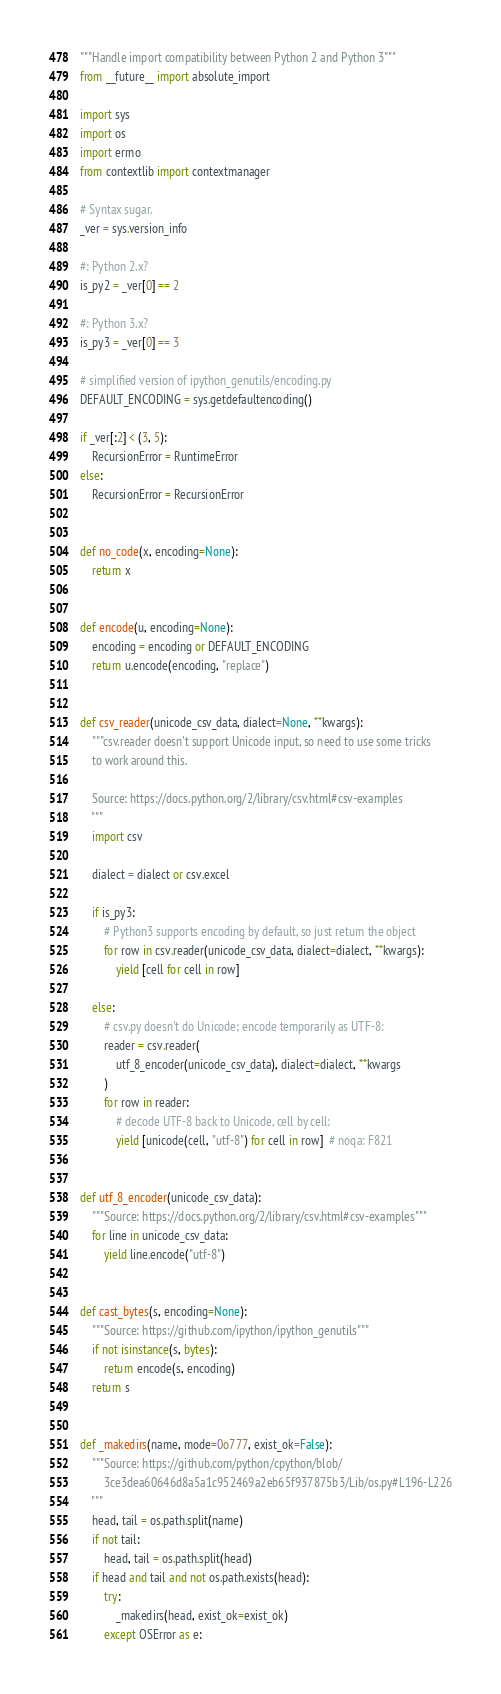<code> <loc_0><loc_0><loc_500><loc_500><_Python_>"""Handle import compatibility between Python 2 and Python 3"""
from __future__ import absolute_import

import sys
import os
import errno
from contextlib import contextmanager

# Syntax sugar.
_ver = sys.version_info

#: Python 2.x?
is_py2 = _ver[0] == 2

#: Python 3.x?
is_py3 = _ver[0] == 3

# simplified version of ipython_genutils/encoding.py
DEFAULT_ENCODING = sys.getdefaultencoding()

if _ver[:2] < (3, 5):
    RecursionError = RuntimeError
else:
    RecursionError = RecursionError


def no_code(x, encoding=None):
    return x


def encode(u, encoding=None):
    encoding = encoding or DEFAULT_ENCODING
    return u.encode(encoding, "replace")


def csv_reader(unicode_csv_data, dialect=None, **kwargs):
    """csv.reader doesn't support Unicode input, so need to use some tricks
    to work around this.

    Source: https://docs.python.org/2/library/csv.html#csv-examples
    """
    import csv

    dialect = dialect or csv.excel

    if is_py3:
        # Python3 supports encoding by default, so just return the object
        for row in csv.reader(unicode_csv_data, dialect=dialect, **kwargs):
            yield [cell for cell in row]

    else:
        # csv.py doesn't do Unicode; encode temporarily as UTF-8:
        reader = csv.reader(
            utf_8_encoder(unicode_csv_data), dialect=dialect, **kwargs
        )
        for row in reader:
            # decode UTF-8 back to Unicode, cell by cell:
            yield [unicode(cell, "utf-8") for cell in row]  # noqa: F821


def utf_8_encoder(unicode_csv_data):
    """Source: https://docs.python.org/2/library/csv.html#csv-examples"""
    for line in unicode_csv_data:
        yield line.encode("utf-8")


def cast_bytes(s, encoding=None):
    """Source: https://github.com/ipython/ipython_genutils"""
    if not isinstance(s, bytes):
        return encode(s, encoding)
    return s


def _makedirs(name, mode=0o777, exist_ok=False):
    """Source: https://github.com/python/cpython/blob/
        3ce3dea60646d8a5a1c952469a2eb65f937875b3/Lib/os.py#L196-L226
    """
    head, tail = os.path.split(name)
    if not tail:
        head, tail = os.path.split(head)
    if head and tail and not os.path.exists(head):
        try:
            _makedirs(head, exist_ok=exist_ok)
        except OSError as e:</code> 